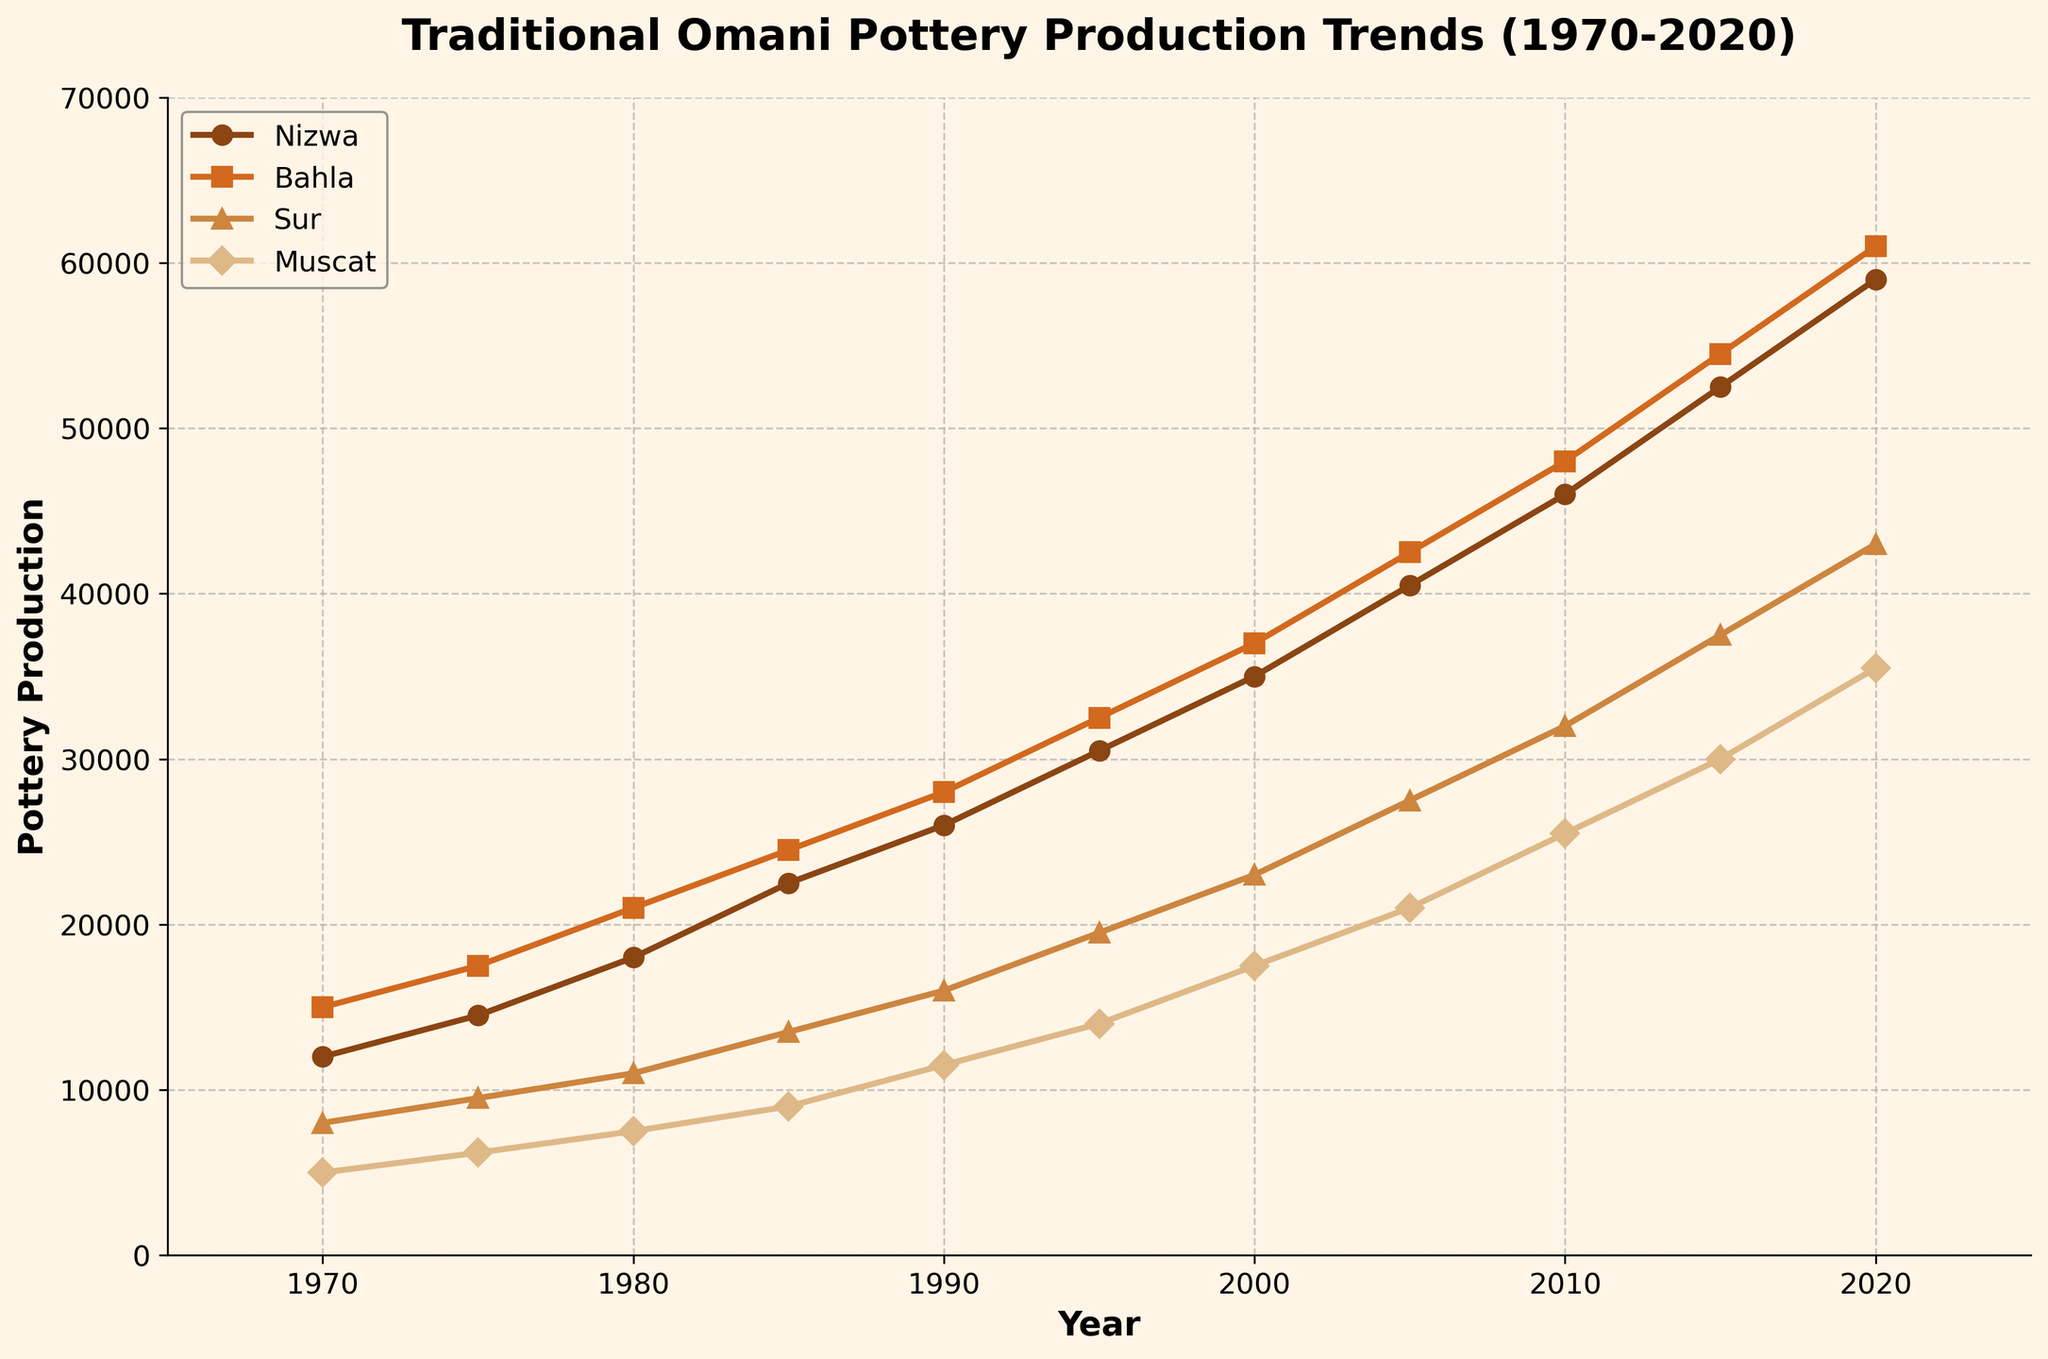What was the pottery production in Bahla and Sur in 1980? From the graph, we can see Bahla had a production of 21,000 units and Sur had a production of 11,000 units in 1980.
Answer: Bahla: 21,000, Sur: 11,000 Between which years did Nizwa see the largest increase in pottery production? Nizwa's production saw the largest jump from 2015 to 2020, increasing from 52,500 to 59,000, a difference of 6,500 units.
Answer: 2015 to 2020 By how much did pottery production increase in Muscat from 1990 to 2000? In 1990, Muscat produced 11,500 units. By 2000, this had increased to 17,500 units. The increase is 17,500 - 11,500 = 6,000 units.
Answer: 6,000 units Which center had the lowest production in 1985, and what was the value? In 1985, Muscat had the lowest production with 9,000 units.
Answer: Muscat: 9,000 units Calculate the average pottery production in Sur over the decade from 1970 to 1980. The values for Sur from 1970 to 1980 are 8,000, 9,500, and 11,000. Sum them up: 8,000 + 9,500 + 11,000 = 28,500. There are three data points, so the average is 28,500 / 3 = 9,500 units.
Answer: 9,500 units Was Bhala's pottery production in 2005 higher or lower than that of Nizwa in 2010? Bhala's pottery production in 2005 was 42,500 units. Nizwa’s production in 2010 was 46,000 units. Therefore, Bhala's production in 2005 was lower than Nizwa's in 2010.
Answer: Lower Which center had the highest production in 2020 and by how much did it exceed the lowest production in the same year? In 2020, Bhala had the highest production with 61,000 units, and Muscat had the lowest with 35,500 units. The difference is 61,000 - 35,500 = 25,500 units.
Answer: Bhala: 25,500 units How many units was the total pottery production of all centers combined in 1995? In 1995, Nizwa produced 30,500 units, Bhala 32,500, Sur 19,500, and Muscat 14,000 units. Summing these, 30,500 + 32,500 + 19,500 + 14,000 = 96,500 units.
Answer: 96,500 units What is the visual trend in pottery production in Nizwa? The chart shows a consistent upward trend in Nizwa’s pottery production from 1970 to 2020.
Answer: Upward trend 